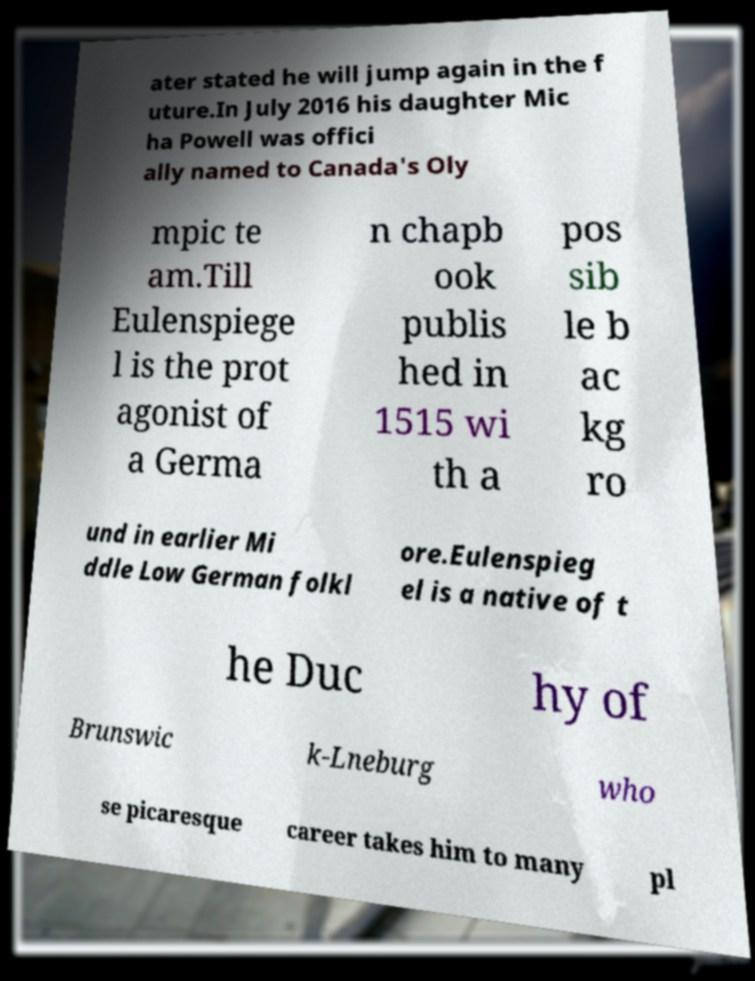Could you assist in decoding the text presented in this image and type it out clearly? ater stated he will jump again in the f uture.In July 2016 his daughter Mic ha Powell was offici ally named to Canada's Oly mpic te am.Till Eulenspiege l is the prot agonist of a Germa n chapb ook publis hed in 1515 wi th a pos sib le b ac kg ro und in earlier Mi ddle Low German folkl ore.Eulenspieg el is a native of t he Duc hy of Brunswic k-Lneburg who se picaresque career takes him to many pl 